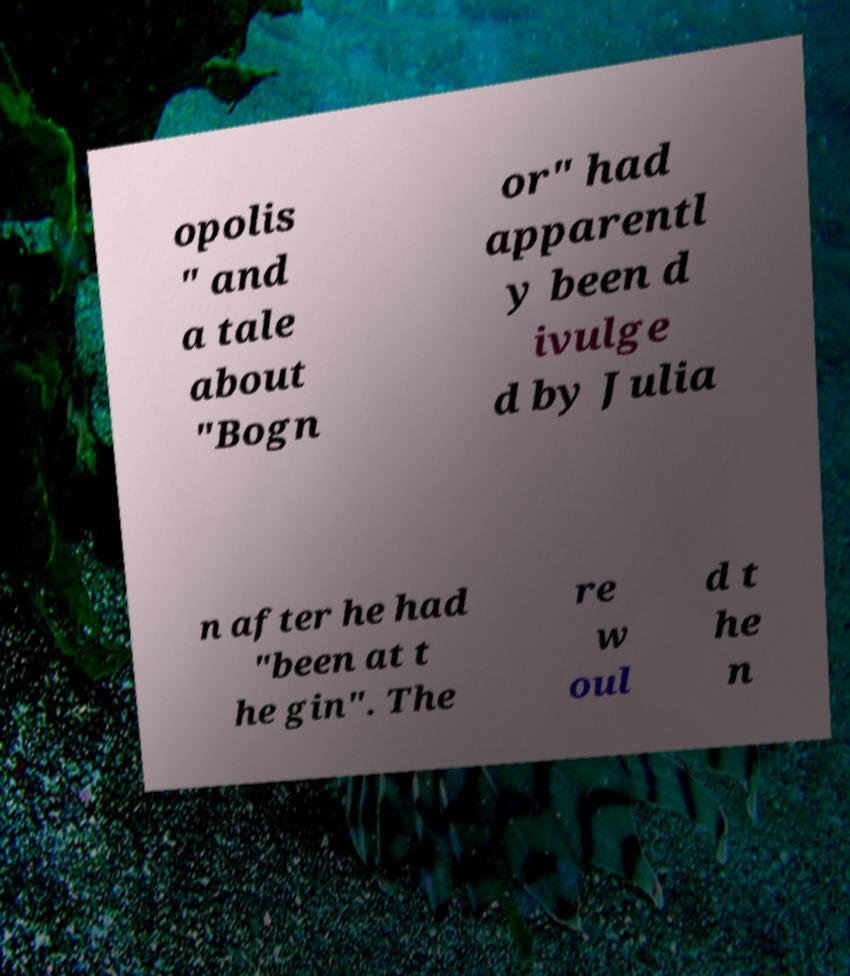There's text embedded in this image that I need extracted. Can you transcribe it verbatim? opolis " and a tale about "Bogn or" had apparentl y been d ivulge d by Julia n after he had "been at t he gin". The re w oul d t he n 